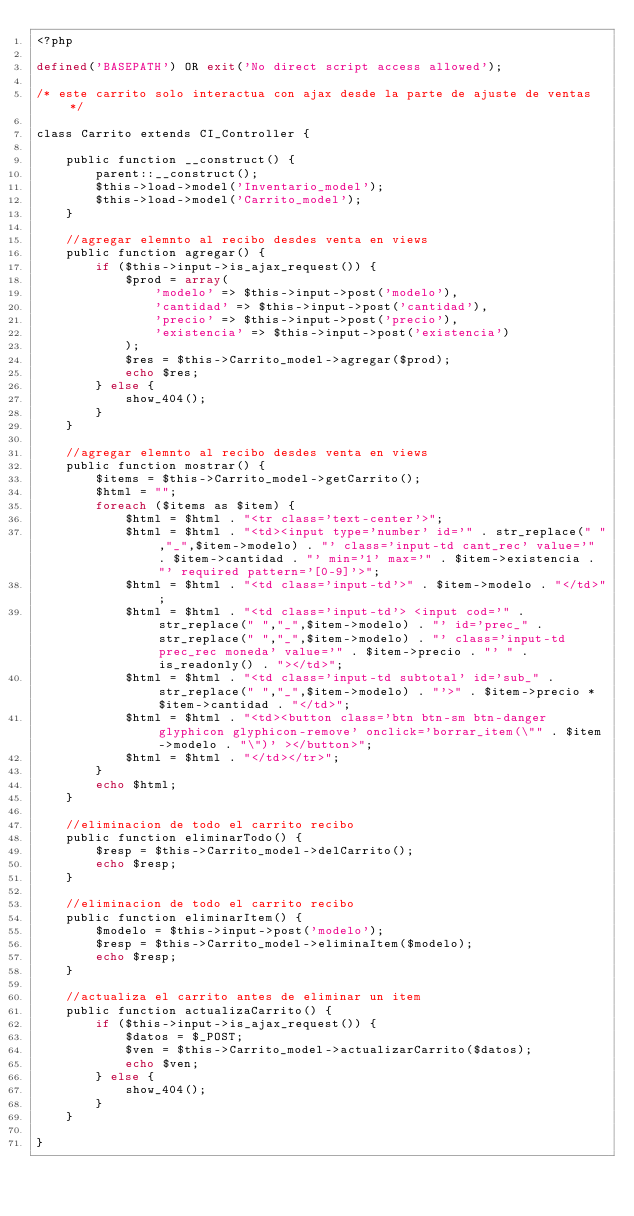Convert code to text. <code><loc_0><loc_0><loc_500><loc_500><_PHP_><?php

defined('BASEPATH') OR exit('No direct script access allowed');

/* este carrito solo interactua con ajax desde la parte de ajuste de ventas */

class Carrito extends CI_Controller {

    public function __construct() {
        parent::__construct();
        $this->load->model('Inventario_model');
        $this->load->model('Carrito_model');
    }

    //agregar elemnto al recibo desdes venta en views
    public function agregar() {
        if ($this->input->is_ajax_request()) {
            $prod = array(
                'modelo' => $this->input->post('modelo'),
                'cantidad' => $this->input->post('cantidad'),
                'precio' => $this->input->post('precio'),
                'existencia' => $this->input->post('existencia')
            );
            $res = $this->Carrito_model->agregar($prod);
            echo $res;
        } else {
            show_404();
        }
    }

    //agregar elemnto al recibo desdes venta en views
    public function mostrar() {
        $items = $this->Carrito_model->getCarrito();
        $html = "";
        foreach ($items as $item) {
            $html = $html . "<tr class='text-center'>";
            $html = $html . "<td><input type='number' id='" . str_replace(" ","_",$item->modelo) . "' class='input-td cant_rec' value='" . $item->cantidad . "' min='1' max='" . $item->existencia . "' required pattern='[0-9]'>";
            $html = $html . "<td class='input-td'>" . $item->modelo . "</td>";
            $html = $html . "<td class='input-td'> <input cod='" . str_replace(" ","_",$item->modelo) . "' id='prec_" . str_replace(" ","_",$item->modelo) . "' class='input-td prec_rec moneda' value='" . $item->precio . "' " . is_readonly() . "></td>";
            $html = $html . "<td class='input-td subtotal' id='sub_" . str_replace(" ","_",$item->modelo) . "'>" . $item->precio * $item->cantidad . "</td>";
            $html = $html . "<td><button class='btn btn-sm btn-danger glyphicon glyphicon-remove' onclick='borrar_item(\"" . $item->modelo . "\")' ></button>";
            $html = $html . "</td></tr>";
        }
        echo $html;
    }

    //eliminacion de todo el carrito recibo
    public function eliminarTodo() {
        $resp = $this->Carrito_model->delCarrito();
        echo $resp;
    }

    //eliminacion de todo el carrito recibo
    public function eliminarItem() {
        $modelo = $this->input->post('modelo');
        $resp = $this->Carrito_model->eliminaItem($modelo);
        echo $resp;
    }

    //actualiza el carrito antes de eliminar un item
    public function actualizaCarrito() {
        if ($this->input->is_ajax_request()) {
            $datos = $_POST;
            $ven = $this->Carrito_model->actualizarCarrito($datos);
            echo $ven;
        } else {
            show_404();
        }
    }

}
</code> 